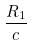Convert formula to latex. <formula><loc_0><loc_0><loc_500><loc_500>\frac { R _ { 1 } } { c }</formula> 